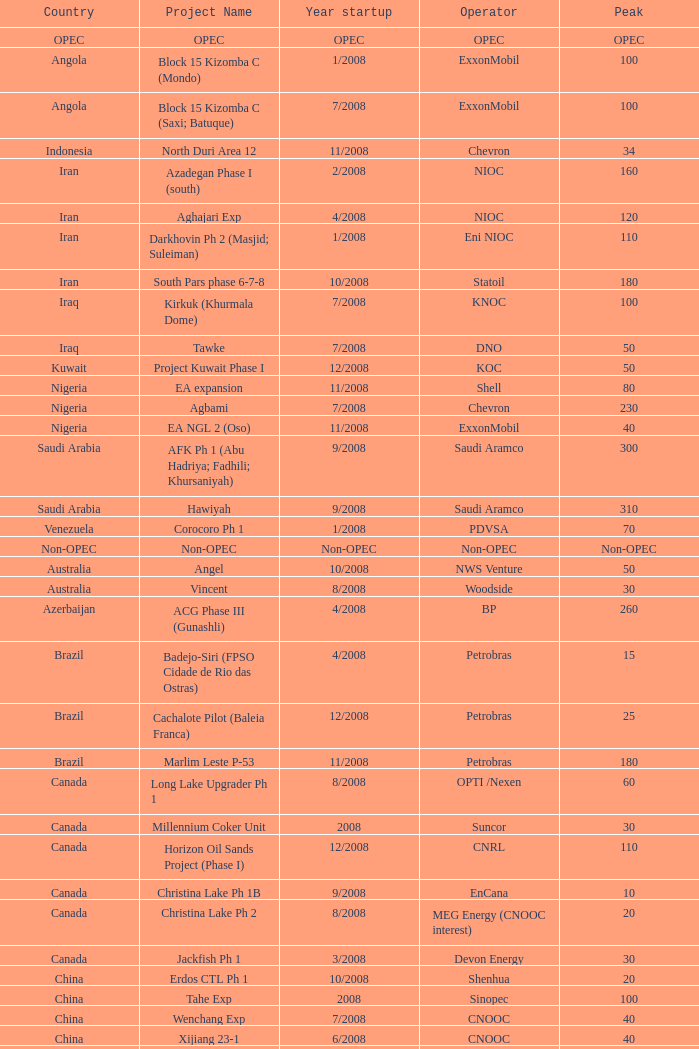What is the project designation associated with a nation such as kazakhstan and a pinnacle of 150? Dunga. Would you be able to parse every entry in this table? {'header': ['Country', 'Project Name', 'Year startup', 'Operator', 'Peak'], 'rows': [['OPEC', 'OPEC', 'OPEC', 'OPEC', 'OPEC'], ['Angola', 'Block 15 Kizomba C (Mondo)', '1/2008', 'ExxonMobil', '100'], ['Angola', 'Block 15 Kizomba C (Saxi; Batuque)', '7/2008', 'ExxonMobil', '100'], ['Indonesia', 'North Duri Area 12', '11/2008', 'Chevron', '34'], ['Iran', 'Azadegan Phase I (south)', '2/2008', 'NIOC', '160'], ['Iran', 'Aghajari Exp', '4/2008', 'NIOC', '120'], ['Iran', 'Darkhovin Ph 2 (Masjid; Suleiman)', '1/2008', 'Eni NIOC', '110'], ['Iran', 'South Pars phase 6-7-8', '10/2008', 'Statoil', '180'], ['Iraq', 'Kirkuk (Khurmala Dome)', '7/2008', 'KNOC', '100'], ['Iraq', 'Tawke', '7/2008', 'DNO', '50'], ['Kuwait', 'Project Kuwait Phase I', '12/2008', 'KOC', '50'], ['Nigeria', 'EA expansion', '11/2008', 'Shell', '80'], ['Nigeria', 'Agbami', '7/2008', 'Chevron', '230'], ['Nigeria', 'EA NGL 2 (Oso)', '11/2008', 'ExxonMobil', '40'], ['Saudi Arabia', 'AFK Ph 1 (Abu Hadriya; Fadhili; Khursaniyah)', '9/2008', 'Saudi Aramco', '300'], ['Saudi Arabia', 'Hawiyah', '9/2008', 'Saudi Aramco', '310'], ['Venezuela', 'Corocoro Ph 1', '1/2008', 'PDVSA', '70'], ['Non-OPEC', 'Non-OPEC', 'Non-OPEC', 'Non-OPEC', 'Non-OPEC'], ['Australia', 'Angel', '10/2008', 'NWS Venture', '50'], ['Australia', 'Vincent', '8/2008', 'Woodside', '30'], ['Azerbaijan', 'ACG Phase III (Gunashli)', '4/2008', 'BP', '260'], ['Brazil', 'Badejo-Siri (FPSO Cidade de Rio das Ostras)', '4/2008', 'Petrobras', '15'], ['Brazil', 'Cachalote Pilot (Baleia Franca)', '12/2008', 'Petrobras', '25'], ['Brazil', 'Marlim Leste P-53', '11/2008', 'Petrobras', '180'], ['Canada', 'Long Lake Upgrader Ph 1', '8/2008', 'OPTI /Nexen', '60'], ['Canada', 'Millennium Coker Unit', '2008', 'Suncor', '30'], ['Canada', 'Horizon Oil Sands Project (Phase I)', '12/2008', 'CNRL', '110'], ['Canada', 'Christina Lake Ph 1B', '9/2008', 'EnCana', '10'], ['Canada', 'Christina Lake Ph 2', '8/2008', 'MEG Energy (CNOOC interest)', '20'], ['Canada', 'Jackfish Ph 1', '3/2008', 'Devon Energy', '30'], ['China', 'Erdos CTL Ph 1', '10/2008', 'Shenhua', '20'], ['China', 'Tahe Exp', '2008', 'Sinopec', '100'], ['China', 'Wenchang Exp', '7/2008', 'CNOOC', '40'], ['China', 'Xijiang 23-1', '6/2008', 'CNOOC', '40'], ['Congo', 'Moho Bilondo', '4/2008', 'Total', '90'], ['Egypt', 'Saqqara', '3/2008', 'BP', '40'], ['India', 'MA field (KG-D6)', '9/2008', 'Reliance', '40'], ['Kazakhstan', 'Dunga', '3/2008', 'Maersk', '150'], ['Kazakhstan', 'Komsomolskoe', '5/2008', 'Petrom', '10'], ['Mexico', '( Chicontepec ) Exp 1', '2008', 'PEMEX', '200'], ['Mexico', 'Antonio J Bermudez Exp', '5/2008', 'PEMEX', '20'], ['Mexico', 'Bellota Chinchorro Exp', '5/2008', 'PEMEX', '20'], ['Mexico', 'Ixtal Manik', '2008', 'PEMEX', '55'], ['Mexico', 'Jujo Tecominoacan Exp', '2008', 'PEMEX', '15'], ['Norway', 'Alvheim; Volund; Vilje', '6/2008', 'Marathon', '100'], ['Norway', 'Volve', '2/2008', 'StatoilHydro', '35'], ['Oman', 'Mukhaizna EOR Ph 1', '2008', 'Occidental', '40'], ['Philippines', 'Galoc', '10/2008', 'GPC', '15'], ['Russia', 'Talakan Ph 1', '10/2008', 'Surgutneftegaz', '60'], ['Russia', 'Verkhnechonsk Ph 1 (early oil)', '10/2008', 'TNK-BP Rosneft', '20'], ['Russia', 'Yuzhno-Khylchuyuskoye "YK" Ph 1', '8/2008', 'Lukoil ConocoPhillips', '75'], ['Thailand', 'Bualuang', '8/2008', 'Salamander', '10'], ['UK', 'Britannia Satellites (Callanish; Brodgar)', '7/2008', 'Conoco Phillips', '25'], ['USA', 'Blind Faith', '11/2008', 'Chevron', '45'], ['USA', 'Neptune', '7/2008', 'BHP Billiton', '25'], ['USA', 'Oooguruk', '6/2008', 'Pioneer', '15'], ['USA', 'Qannik', '7/2008', 'ConocoPhillips', '4'], ['USA', 'Thunder Horse', '6/2008', 'BP', '210'], ['USA', 'Ursa Princess Exp', '1/2008', 'Shell', '30'], ['Vietnam', 'Ca Ngu Vang (Golden Tuna)', '7/2008', 'HVJOC', '15'], ['Vietnam', 'Su Tu Vang', '10/2008', 'Cuu Long Joint', '40'], ['Vietnam', 'Song Doc', '12/2008', 'Talisman', '10']]} 